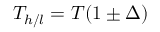<formula> <loc_0><loc_0><loc_500><loc_500>T _ { h / l } = T ( 1 \pm \Delta )</formula> 